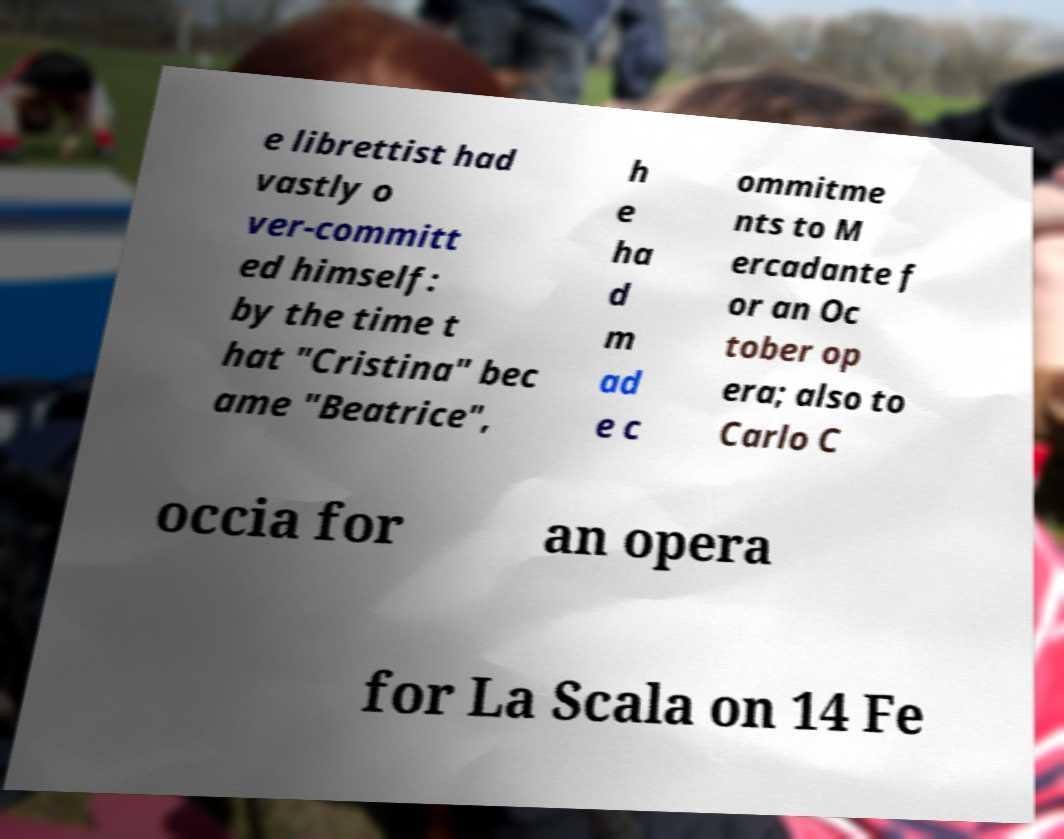Can you read and provide the text displayed in the image?This photo seems to have some interesting text. Can you extract and type it out for me? e librettist had vastly o ver-committ ed himself: by the time t hat "Cristina" bec ame "Beatrice", h e ha d m ad e c ommitme nts to M ercadante f or an Oc tober op era; also to Carlo C occia for an opera for La Scala on 14 Fe 